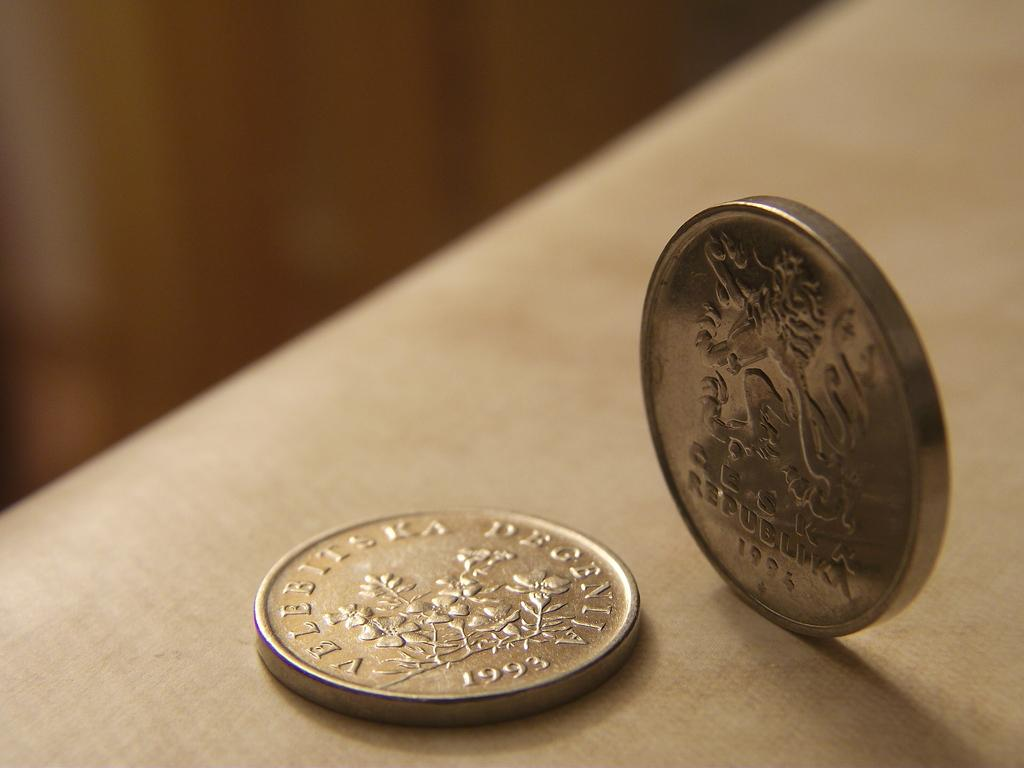Provide a one-sentence caption for the provided image. A foreign coin from 1993 with the words Velebitska Degenija on it. 